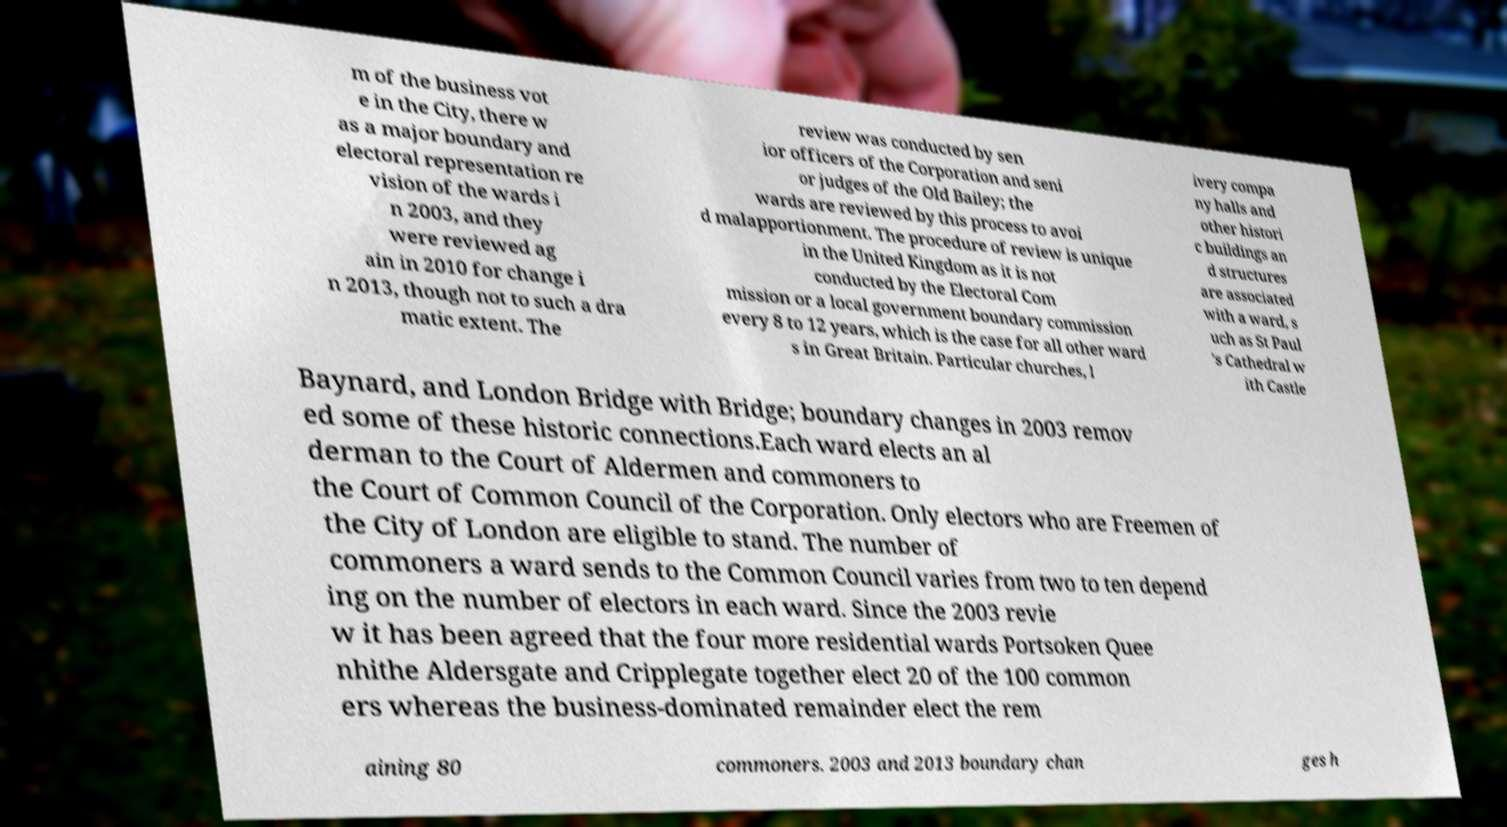Can you accurately transcribe the text from the provided image for me? m of the business vot e in the City, there w as a major boundary and electoral representation re vision of the wards i n 2003, and they were reviewed ag ain in 2010 for change i n 2013, though not to such a dra matic extent. The review was conducted by sen ior officers of the Corporation and seni or judges of the Old Bailey; the wards are reviewed by this process to avoi d malapportionment. The procedure of review is unique in the United Kingdom as it is not conducted by the Electoral Com mission or a local government boundary commission every 8 to 12 years, which is the case for all other ward s in Great Britain. Particular churches, l ivery compa ny halls and other histori c buildings an d structures are associated with a ward, s uch as St Paul 's Cathedral w ith Castle Baynard, and London Bridge with Bridge; boundary changes in 2003 remov ed some of these historic connections.Each ward elects an al derman to the Court of Aldermen and commoners to the Court of Common Council of the Corporation. Only electors who are Freemen of the City of London are eligible to stand. The number of commoners a ward sends to the Common Council varies from two to ten depend ing on the number of electors in each ward. Since the 2003 revie w it has been agreed that the four more residential wards Portsoken Quee nhithe Aldersgate and Cripplegate together elect 20 of the 100 common ers whereas the business-dominated remainder elect the rem aining 80 commoners. 2003 and 2013 boundary chan ges h 